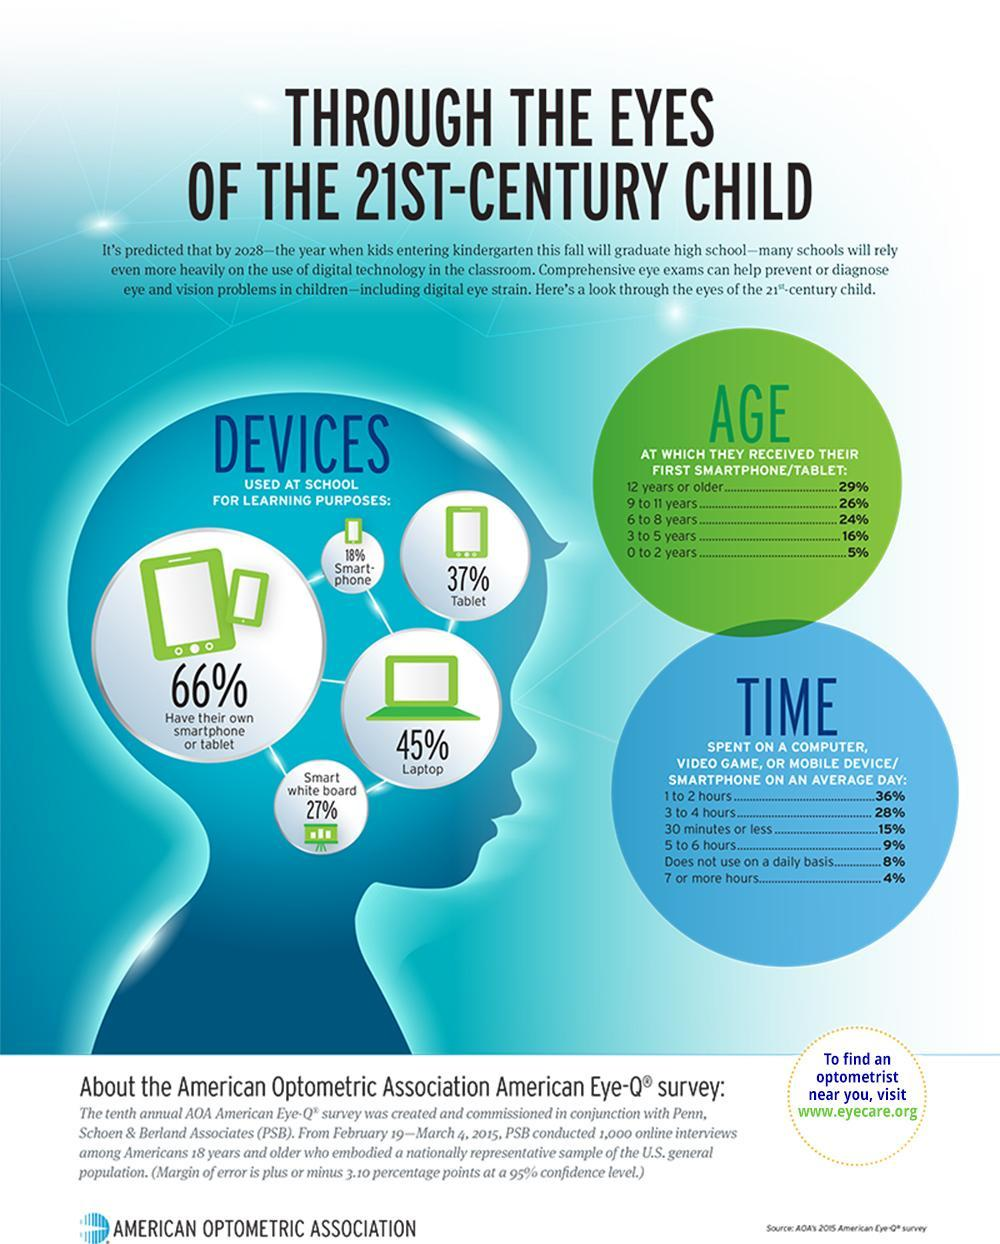Which is higher - number of kids with smartphone or number of kids with tablet?
Answer the question with a short phrase. number of kids with tablet What percent of kids under the age of 9 got their first smartphone/tablet? 45 Which is higher - number of kids with laptop or number of kids with tablet? number of kids with laptop What is the percentage of children who spend 4 or less hours a day on digital devices? 79% Which is lower in number - kids with laptop, kids with tablet or kids with smart phone? kids with smart phone Which is higher - number of kids with smart white board or number of kids with smart phone? number of kids with smart white board how many age groups are given in the table under the heading "age"? 5 What is the percentage of children who spend 5 or more hours a day on digital devices? 13% 